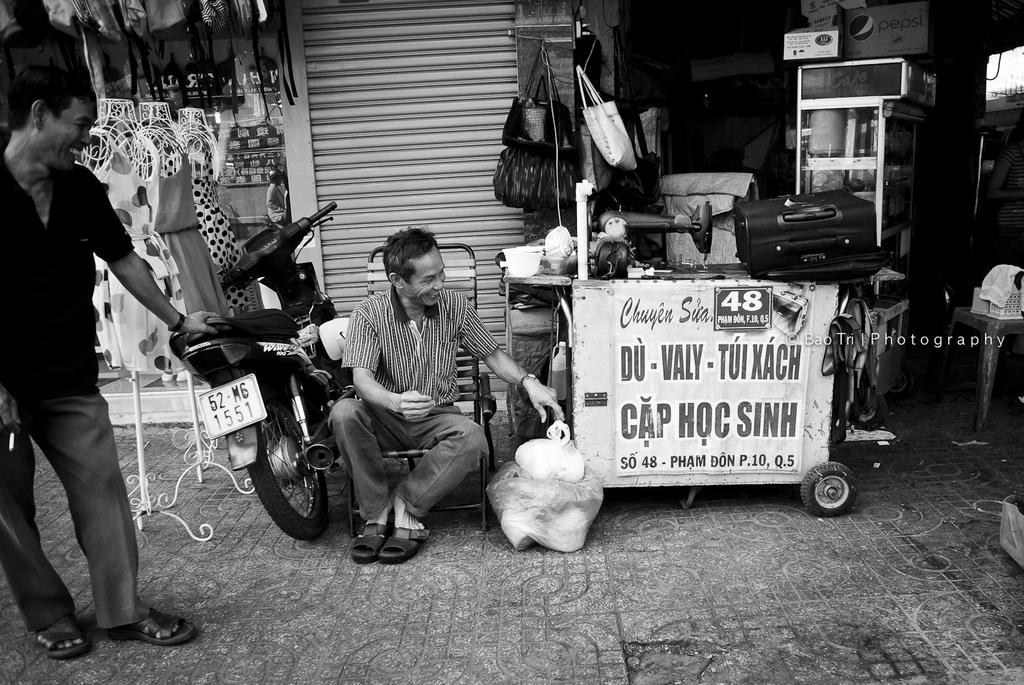Could you give a brief overview of what you see in this image? This image is a black and white image. This image is taken outdoors. At the bottom of the image there is a floor. In the background there are a few stores with handbags, luggage bags, scarves, mannequins, dressed and many things. There is a shutter and there is a stall with a board and text on it. In the middle of the image a man is sitting on the chairs and a bike is parked on the floor. On the left side of the image a man is standing on the floor. 